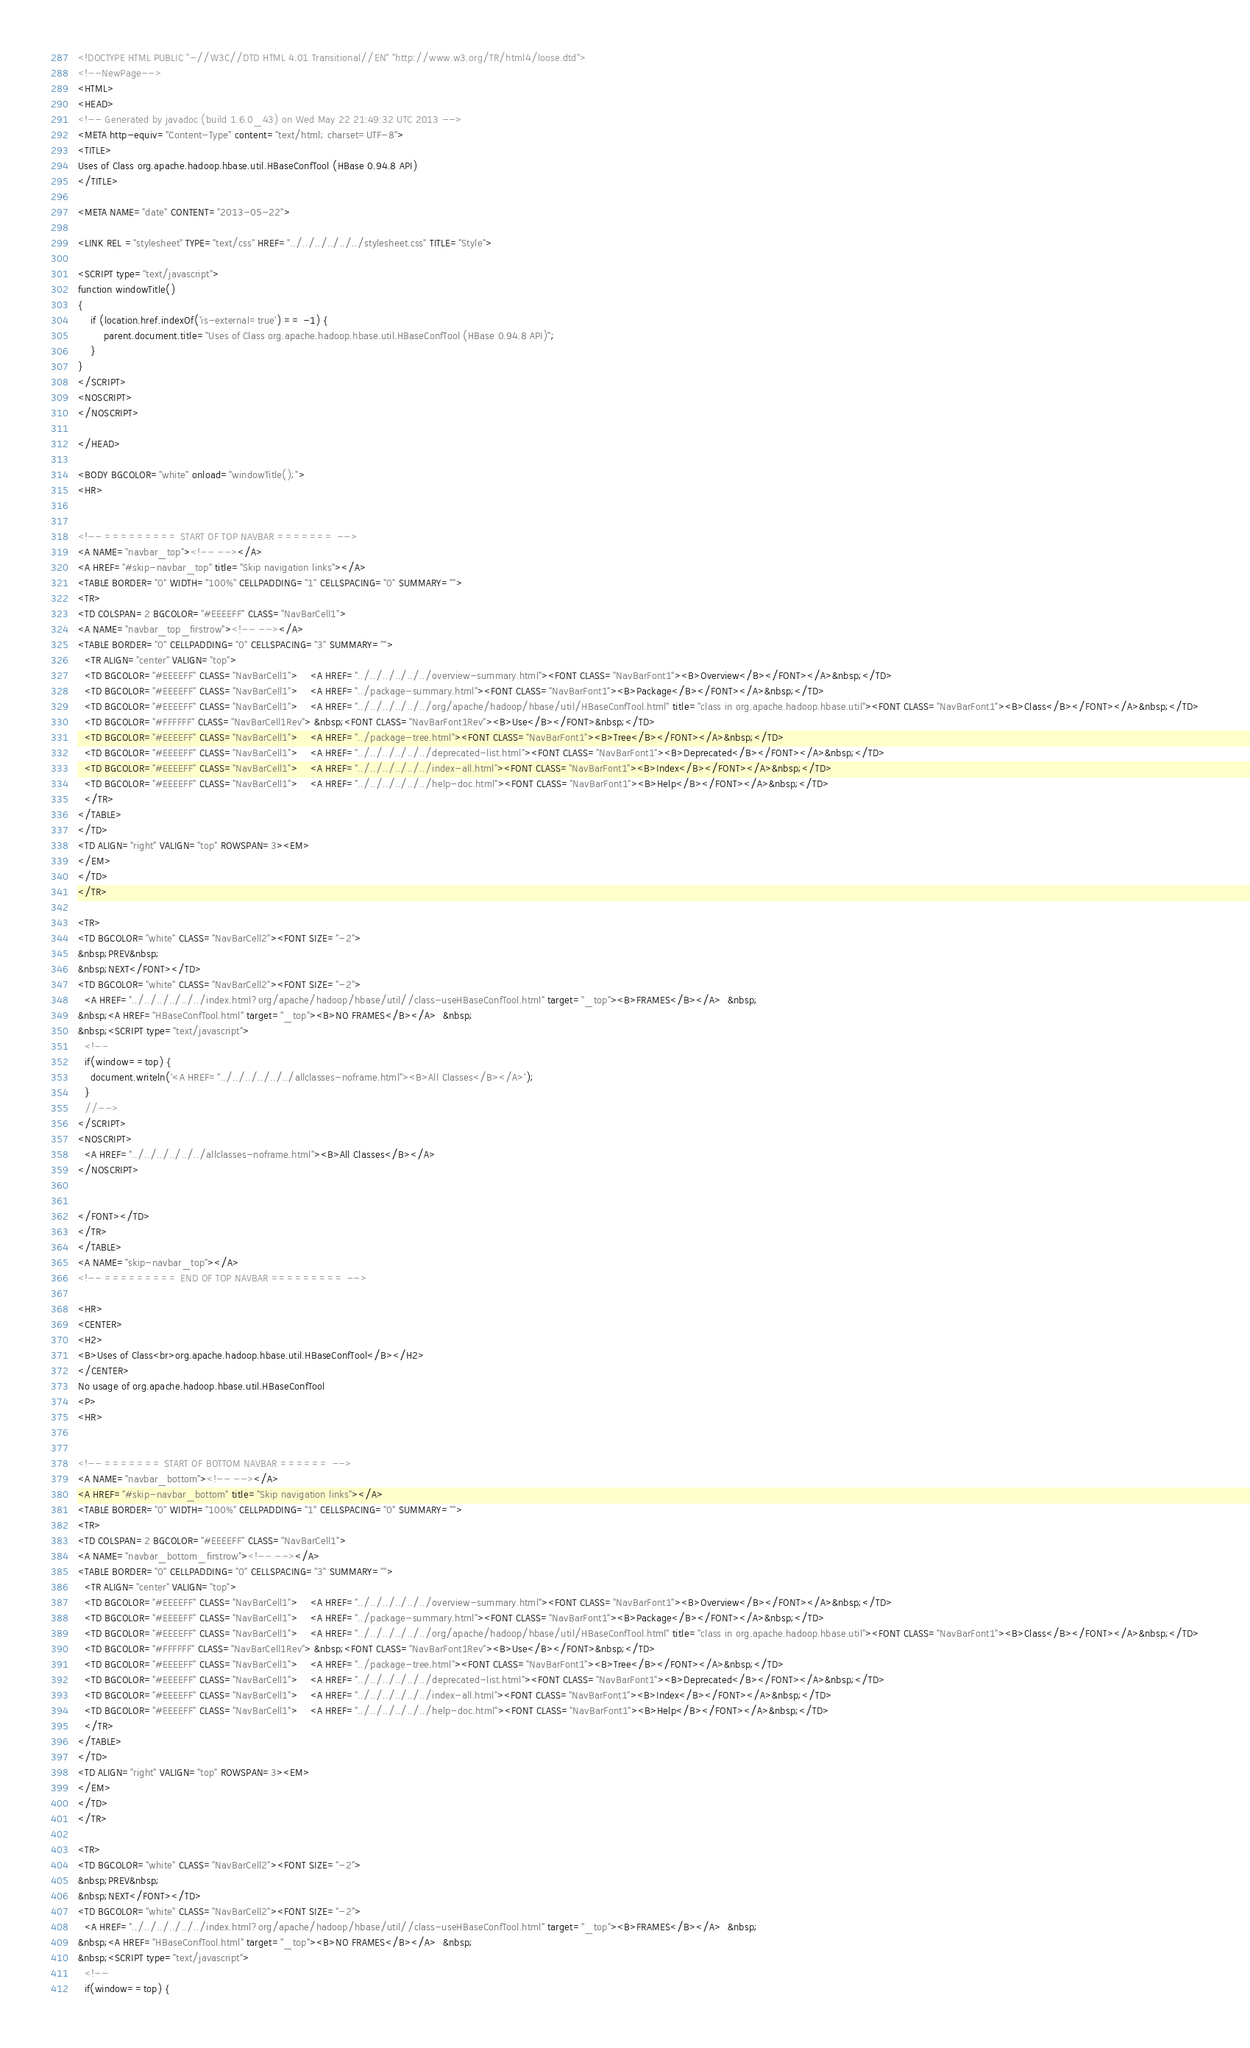<code> <loc_0><loc_0><loc_500><loc_500><_HTML_><!DOCTYPE HTML PUBLIC "-//W3C//DTD HTML 4.01 Transitional//EN" "http://www.w3.org/TR/html4/loose.dtd">
<!--NewPage-->
<HTML>
<HEAD>
<!-- Generated by javadoc (build 1.6.0_43) on Wed May 22 21:49:32 UTC 2013 -->
<META http-equiv="Content-Type" content="text/html; charset=UTF-8">
<TITLE>
Uses of Class org.apache.hadoop.hbase.util.HBaseConfTool (HBase 0.94.8 API)
</TITLE>

<META NAME="date" CONTENT="2013-05-22">

<LINK REL ="stylesheet" TYPE="text/css" HREF="../../../../../../stylesheet.css" TITLE="Style">

<SCRIPT type="text/javascript">
function windowTitle()
{
    if (location.href.indexOf('is-external=true') == -1) {
        parent.document.title="Uses of Class org.apache.hadoop.hbase.util.HBaseConfTool (HBase 0.94.8 API)";
    }
}
</SCRIPT>
<NOSCRIPT>
</NOSCRIPT>

</HEAD>

<BODY BGCOLOR="white" onload="windowTitle();">
<HR>


<!-- ========= START OF TOP NAVBAR ======= -->
<A NAME="navbar_top"><!-- --></A>
<A HREF="#skip-navbar_top" title="Skip navigation links"></A>
<TABLE BORDER="0" WIDTH="100%" CELLPADDING="1" CELLSPACING="0" SUMMARY="">
<TR>
<TD COLSPAN=2 BGCOLOR="#EEEEFF" CLASS="NavBarCell1">
<A NAME="navbar_top_firstrow"><!-- --></A>
<TABLE BORDER="0" CELLPADDING="0" CELLSPACING="3" SUMMARY="">
  <TR ALIGN="center" VALIGN="top">
  <TD BGCOLOR="#EEEEFF" CLASS="NavBarCell1">    <A HREF="../../../../../../overview-summary.html"><FONT CLASS="NavBarFont1"><B>Overview</B></FONT></A>&nbsp;</TD>
  <TD BGCOLOR="#EEEEFF" CLASS="NavBarCell1">    <A HREF="../package-summary.html"><FONT CLASS="NavBarFont1"><B>Package</B></FONT></A>&nbsp;</TD>
  <TD BGCOLOR="#EEEEFF" CLASS="NavBarCell1">    <A HREF="../../../../../../org/apache/hadoop/hbase/util/HBaseConfTool.html" title="class in org.apache.hadoop.hbase.util"><FONT CLASS="NavBarFont1"><B>Class</B></FONT></A>&nbsp;</TD>
  <TD BGCOLOR="#FFFFFF" CLASS="NavBarCell1Rev"> &nbsp;<FONT CLASS="NavBarFont1Rev"><B>Use</B></FONT>&nbsp;</TD>
  <TD BGCOLOR="#EEEEFF" CLASS="NavBarCell1">    <A HREF="../package-tree.html"><FONT CLASS="NavBarFont1"><B>Tree</B></FONT></A>&nbsp;</TD>
  <TD BGCOLOR="#EEEEFF" CLASS="NavBarCell1">    <A HREF="../../../../../../deprecated-list.html"><FONT CLASS="NavBarFont1"><B>Deprecated</B></FONT></A>&nbsp;</TD>
  <TD BGCOLOR="#EEEEFF" CLASS="NavBarCell1">    <A HREF="../../../../../../index-all.html"><FONT CLASS="NavBarFont1"><B>Index</B></FONT></A>&nbsp;</TD>
  <TD BGCOLOR="#EEEEFF" CLASS="NavBarCell1">    <A HREF="../../../../../../help-doc.html"><FONT CLASS="NavBarFont1"><B>Help</B></FONT></A>&nbsp;</TD>
  </TR>
</TABLE>
</TD>
<TD ALIGN="right" VALIGN="top" ROWSPAN=3><EM>
</EM>
</TD>
</TR>

<TR>
<TD BGCOLOR="white" CLASS="NavBarCell2"><FONT SIZE="-2">
&nbsp;PREV&nbsp;
&nbsp;NEXT</FONT></TD>
<TD BGCOLOR="white" CLASS="NavBarCell2"><FONT SIZE="-2">
  <A HREF="../../../../../../index.html?org/apache/hadoop/hbase/util//class-useHBaseConfTool.html" target="_top"><B>FRAMES</B></A>  &nbsp;
&nbsp;<A HREF="HBaseConfTool.html" target="_top"><B>NO FRAMES</B></A>  &nbsp;
&nbsp;<SCRIPT type="text/javascript">
  <!--
  if(window==top) {
    document.writeln('<A HREF="../../../../../../allclasses-noframe.html"><B>All Classes</B></A>');
  }
  //-->
</SCRIPT>
<NOSCRIPT>
  <A HREF="../../../../../../allclasses-noframe.html"><B>All Classes</B></A>
</NOSCRIPT>


</FONT></TD>
</TR>
</TABLE>
<A NAME="skip-navbar_top"></A>
<!-- ========= END OF TOP NAVBAR ========= -->

<HR>
<CENTER>
<H2>
<B>Uses of Class<br>org.apache.hadoop.hbase.util.HBaseConfTool</B></H2>
</CENTER>
No usage of org.apache.hadoop.hbase.util.HBaseConfTool
<P>
<HR>


<!-- ======= START OF BOTTOM NAVBAR ====== -->
<A NAME="navbar_bottom"><!-- --></A>
<A HREF="#skip-navbar_bottom" title="Skip navigation links"></A>
<TABLE BORDER="0" WIDTH="100%" CELLPADDING="1" CELLSPACING="0" SUMMARY="">
<TR>
<TD COLSPAN=2 BGCOLOR="#EEEEFF" CLASS="NavBarCell1">
<A NAME="navbar_bottom_firstrow"><!-- --></A>
<TABLE BORDER="0" CELLPADDING="0" CELLSPACING="3" SUMMARY="">
  <TR ALIGN="center" VALIGN="top">
  <TD BGCOLOR="#EEEEFF" CLASS="NavBarCell1">    <A HREF="../../../../../../overview-summary.html"><FONT CLASS="NavBarFont1"><B>Overview</B></FONT></A>&nbsp;</TD>
  <TD BGCOLOR="#EEEEFF" CLASS="NavBarCell1">    <A HREF="../package-summary.html"><FONT CLASS="NavBarFont1"><B>Package</B></FONT></A>&nbsp;</TD>
  <TD BGCOLOR="#EEEEFF" CLASS="NavBarCell1">    <A HREF="../../../../../../org/apache/hadoop/hbase/util/HBaseConfTool.html" title="class in org.apache.hadoop.hbase.util"><FONT CLASS="NavBarFont1"><B>Class</B></FONT></A>&nbsp;</TD>
  <TD BGCOLOR="#FFFFFF" CLASS="NavBarCell1Rev"> &nbsp;<FONT CLASS="NavBarFont1Rev"><B>Use</B></FONT>&nbsp;</TD>
  <TD BGCOLOR="#EEEEFF" CLASS="NavBarCell1">    <A HREF="../package-tree.html"><FONT CLASS="NavBarFont1"><B>Tree</B></FONT></A>&nbsp;</TD>
  <TD BGCOLOR="#EEEEFF" CLASS="NavBarCell1">    <A HREF="../../../../../../deprecated-list.html"><FONT CLASS="NavBarFont1"><B>Deprecated</B></FONT></A>&nbsp;</TD>
  <TD BGCOLOR="#EEEEFF" CLASS="NavBarCell1">    <A HREF="../../../../../../index-all.html"><FONT CLASS="NavBarFont1"><B>Index</B></FONT></A>&nbsp;</TD>
  <TD BGCOLOR="#EEEEFF" CLASS="NavBarCell1">    <A HREF="../../../../../../help-doc.html"><FONT CLASS="NavBarFont1"><B>Help</B></FONT></A>&nbsp;</TD>
  </TR>
</TABLE>
</TD>
<TD ALIGN="right" VALIGN="top" ROWSPAN=3><EM>
</EM>
</TD>
</TR>

<TR>
<TD BGCOLOR="white" CLASS="NavBarCell2"><FONT SIZE="-2">
&nbsp;PREV&nbsp;
&nbsp;NEXT</FONT></TD>
<TD BGCOLOR="white" CLASS="NavBarCell2"><FONT SIZE="-2">
  <A HREF="../../../../../../index.html?org/apache/hadoop/hbase/util//class-useHBaseConfTool.html" target="_top"><B>FRAMES</B></A>  &nbsp;
&nbsp;<A HREF="HBaseConfTool.html" target="_top"><B>NO FRAMES</B></A>  &nbsp;
&nbsp;<SCRIPT type="text/javascript">
  <!--
  if(window==top) {</code> 